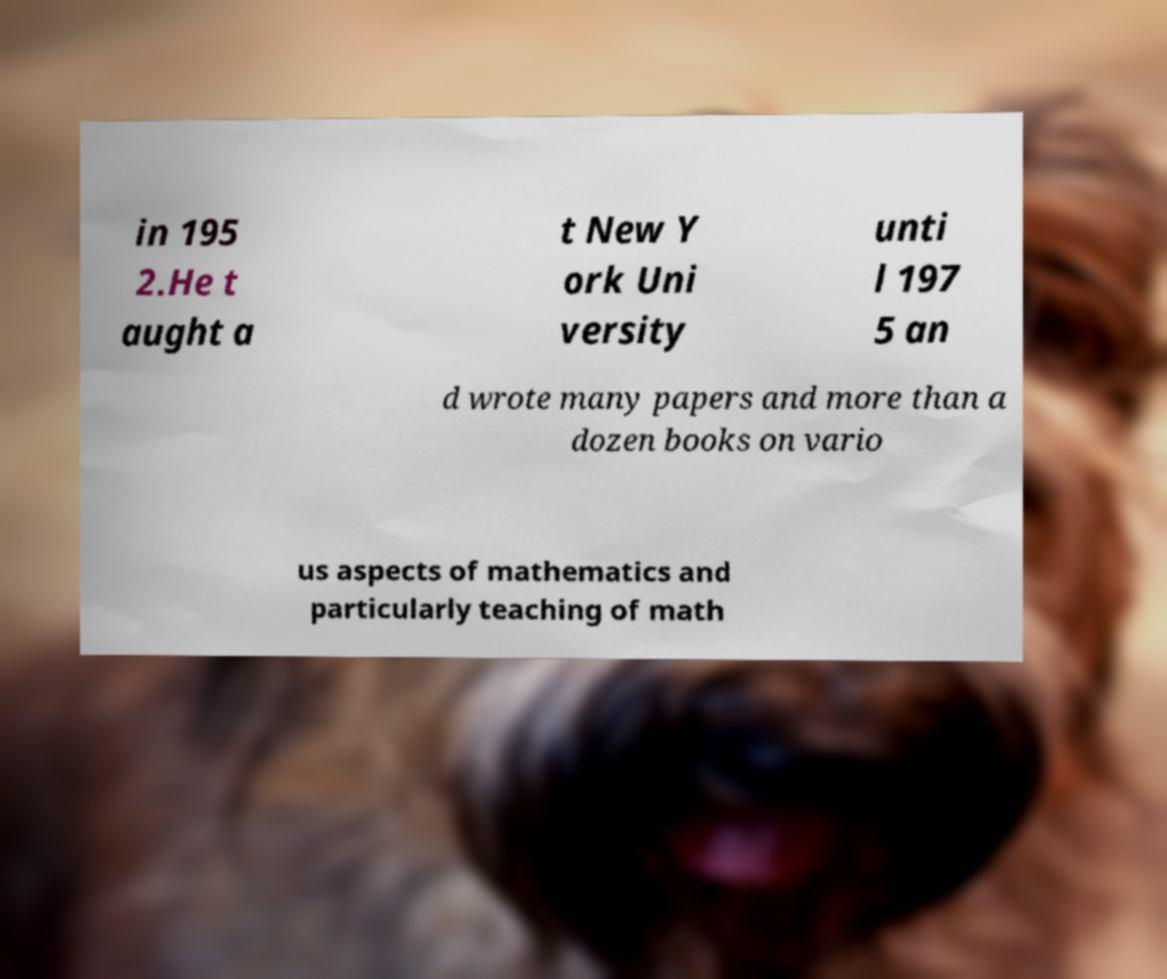For documentation purposes, I need the text within this image transcribed. Could you provide that? in 195 2.He t aught a t New Y ork Uni versity unti l 197 5 an d wrote many papers and more than a dozen books on vario us aspects of mathematics and particularly teaching of math 